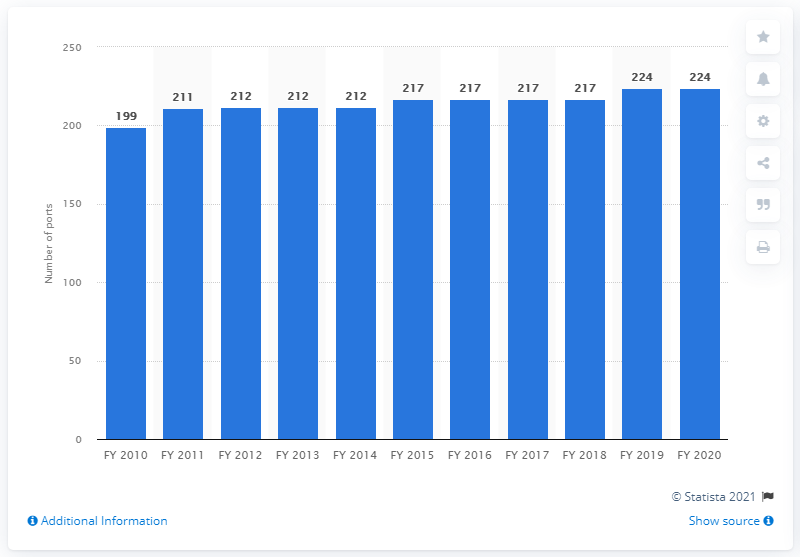Draw attention to some important aspects in this diagram. In the financial year 2020, the total number of ports in India was 224. 